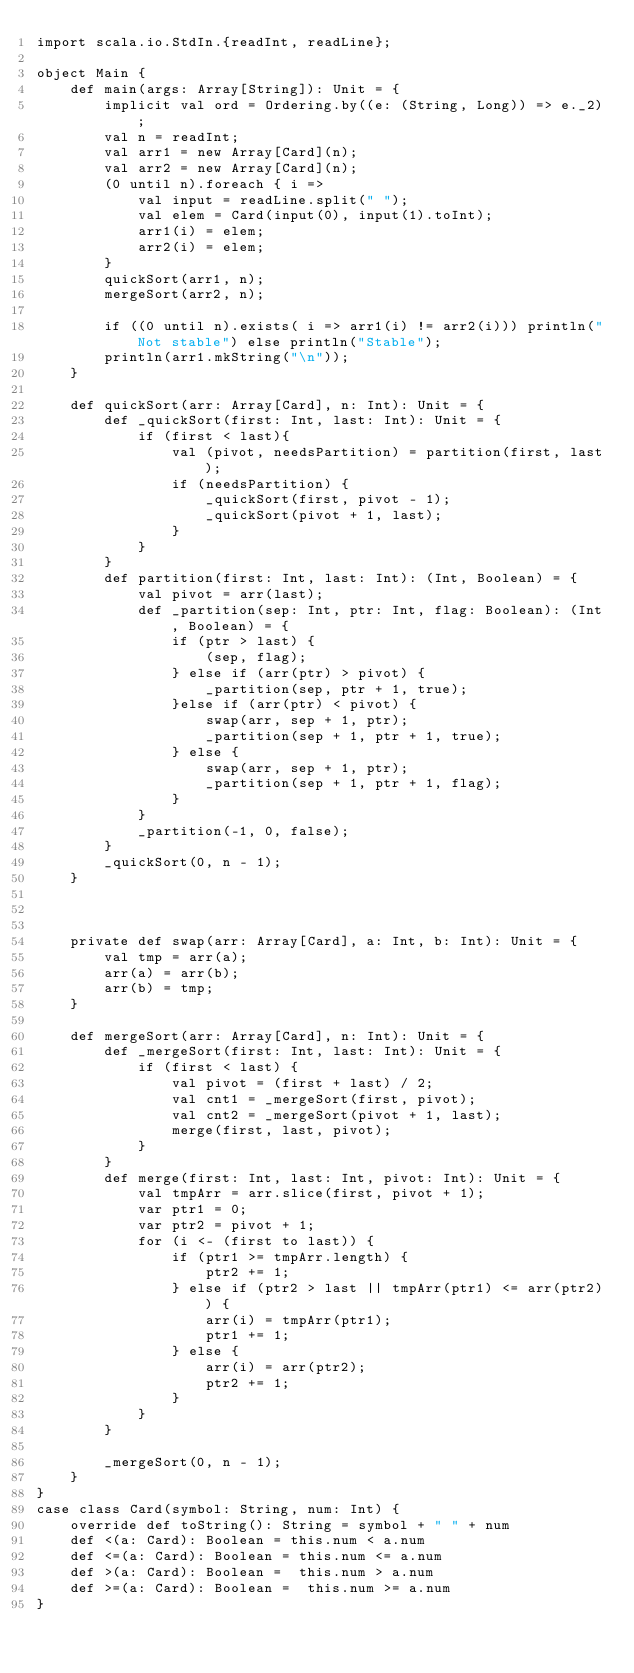<code> <loc_0><loc_0><loc_500><loc_500><_Scala_>import scala.io.StdIn.{readInt, readLine};

object Main {
    def main(args: Array[String]): Unit = {
        implicit val ord = Ordering.by((e: (String, Long)) => e._2);
        val n = readInt;
        val arr1 = new Array[Card](n);
        val arr2 = new Array[Card](n);
        (0 until n).foreach { i => 
            val input = readLine.split(" ");
            val elem = Card(input(0), input(1).toInt);
            arr1(i) = elem;
            arr2(i) = elem;
        }
        quickSort(arr1, n);
        mergeSort(arr2, n);
        
        if ((0 until n).exists( i => arr1(i) != arr2(i))) println("Not stable") else println("Stable");
        println(arr1.mkString("\n"));
    }
    
    def quickSort(arr: Array[Card], n: Int): Unit = {
        def _quickSort(first: Int, last: Int): Unit = {
            if (first < last){
                val (pivot, needsPartition) = partition(first, last);
                if (needsPartition) {
                    _quickSort(first, pivot - 1);
                    _quickSort(pivot + 1, last);
                }
            }
        }
        def partition(first: Int, last: Int): (Int, Boolean) = {
            val pivot = arr(last);
            def _partition(sep: Int, ptr: Int, flag: Boolean): (Int, Boolean) = {
                if (ptr > last) {
                    (sep, flag);
                } else if (arr(ptr) > pivot) {
                    _partition(sep, ptr + 1, true);
                }else if (arr(ptr) < pivot) {
                    swap(arr, sep + 1, ptr);
                    _partition(sep + 1, ptr + 1, true);
                } else {
                    swap(arr, sep + 1, ptr);
                    _partition(sep + 1, ptr + 1, flag);
                }
            }
            _partition(-1, 0, false);
        }
        _quickSort(0, n - 1);
    }
    


    private def swap(arr: Array[Card], a: Int, b: Int): Unit = {
        val tmp = arr(a);
        arr(a) = arr(b);
        arr(b) = tmp;
    }
    
    def mergeSort(arr: Array[Card], n: Int): Unit = {
        def _mergeSort(first: Int, last: Int): Unit = {
            if (first < last) {
                val pivot = (first + last) / 2;
                val cnt1 = _mergeSort(first, pivot);
                val cnt2 = _mergeSort(pivot + 1, last);
                merge(first, last, pivot);
            }
        }
        def merge(first: Int, last: Int, pivot: Int): Unit = {
            val tmpArr = arr.slice(first, pivot + 1);
            var ptr1 = 0;
            var ptr2 = pivot + 1;
            for (i <- (first to last)) {
                if (ptr1 >= tmpArr.length) {
                    ptr2 += 1;
                } else if (ptr2 > last || tmpArr(ptr1) <= arr(ptr2)) {
                    arr(i) = tmpArr(ptr1);
                    ptr1 += 1;
                } else {
                    arr(i) = arr(ptr2);
                    ptr2 += 1;
                }
            }
        }
        
        _mergeSort(0, n - 1);
    }
}
case class Card(symbol: String, num: Int) {
    override def toString(): String = symbol + " " + num
    def <(a: Card): Boolean = this.num < a.num
    def <=(a: Card): Boolean = this.num <= a.num
    def >(a: Card): Boolean =  this.num > a.num
    def >=(a: Card): Boolean =  this.num >= a.num
}
</code> 